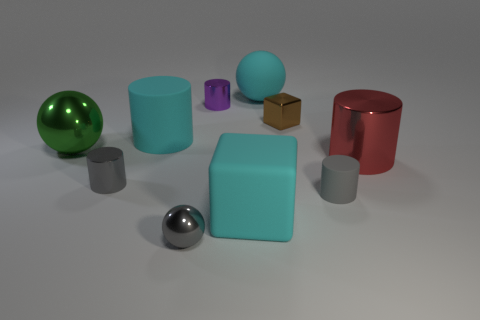Subtract all large matte cylinders. How many cylinders are left? 4 Subtract all purple cylinders. How many cylinders are left? 4 Subtract all brown cylinders. Subtract all blue balls. How many cylinders are left? 5 Subtract all balls. How many objects are left? 7 Subtract 0 green cubes. How many objects are left? 10 Subtract all brown blocks. Subtract all tiny metallic things. How many objects are left? 5 Add 3 large things. How many large things are left? 8 Add 4 tiny cubes. How many tiny cubes exist? 5 